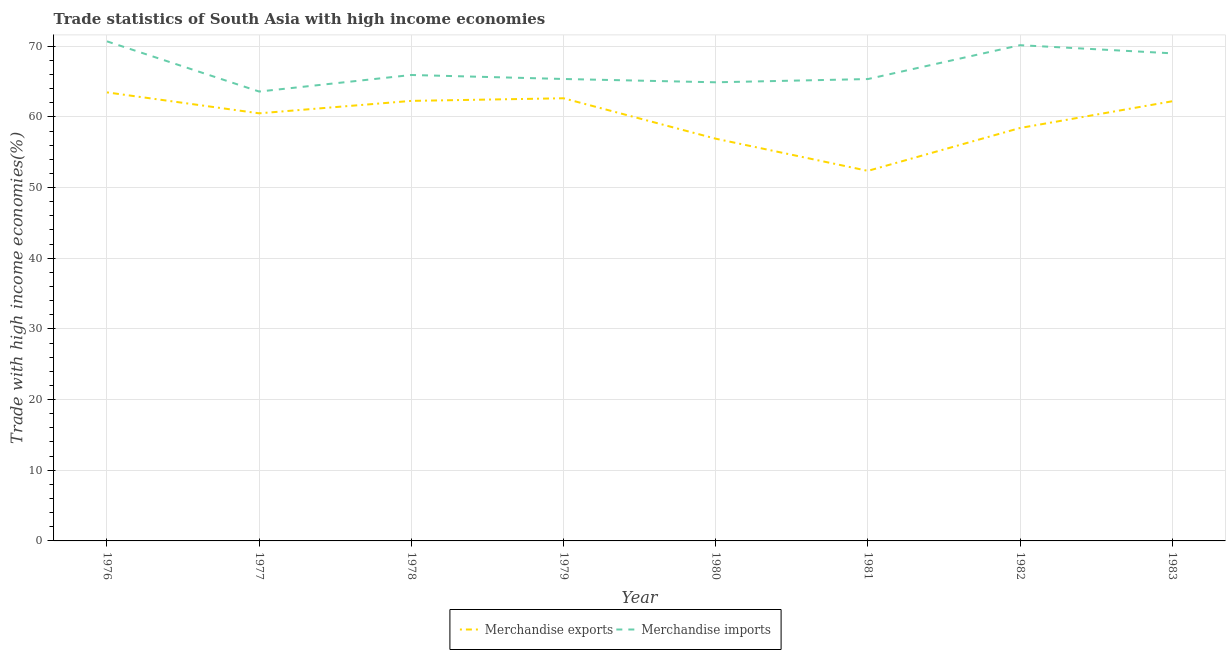How many different coloured lines are there?
Your answer should be compact. 2. Does the line corresponding to merchandise exports intersect with the line corresponding to merchandise imports?
Your answer should be compact. No. Is the number of lines equal to the number of legend labels?
Offer a very short reply. Yes. What is the merchandise imports in 1977?
Your answer should be very brief. 63.58. Across all years, what is the maximum merchandise imports?
Keep it short and to the point. 70.69. Across all years, what is the minimum merchandise exports?
Offer a very short reply. 52.36. In which year was the merchandise exports maximum?
Provide a succinct answer. 1976. What is the total merchandise exports in the graph?
Your response must be concise. 478.78. What is the difference between the merchandise imports in 1979 and that in 1980?
Give a very brief answer. 0.47. What is the difference between the merchandise imports in 1983 and the merchandise exports in 1981?
Your answer should be compact. 16.63. What is the average merchandise exports per year?
Your answer should be compact. 59.85. In the year 1977, what is the difference between the merchandise exports and merchandise imports?
Your response must be concise. -3.08. In how many years, is the merchandise exports greater than 32 %?
Offer a very short reply. 8. What is the ratio of the merchandise imports in 1976 to that in 1980?
Your answer should be very brief. 1.09. Is the merchandise imports in 1981 less than that in 1983?
Keep it short and to the point. Yes. Is the difference between the merchandise exports in 1978 and 1980 greater than the difference between the merchandise imports in 1978 and 1980?
Your response must be concise. Yes. What is the difference between the highest and the second highest merchandise imports?
Your answer should be very brief. 0.54. What is the difference between the highest and the lowest merchandise exports?
Your answer should be compact. 11.1. Is the sum of the merchandise imports in 1976 and 1979 greater than the maximum merchandise exports across all years?
Make the answer very short. Yes. Does the merchandise exports monotonically increase over the years?
Your answer should be very brief. No. Is the merchandise imports strictly greater than the merchandise exports over the years?
Make the answer very short. Yes. Is the merchandise imports strictly less than the merchandise exports over the years?
Your answer should be compact. No. How many lines are there?
Provide a succinct answer. 2. Does the graph contain grids?
Offer a very short reply. Yes. What is the title of the graph?
Make the answer very short. Trade statistics of South Asia with high income economies. What is the label or title of the Y-axis?
Ensure brevity in your answer.  Trade with high income economies(%). What is the Trade with high income economies(%) of Merchandise exports in 1976?
Offer a terse response. 63.47. What is the Trade with high income economies(%) in Merchandise imports in 1976?
Provide a succinct answer. 70.69. What is the Trade with high income economies(%) in Merchandise exports in 1977?
Keep it short and to the point. 60.5. What is the Trade with high income economies(%) of Merchandise imports in 1977?
Your answer should be very brief. 63.58. What is the Trade with high income economies(%) in Merchandise exports in 1978?
Keep it short and to the point. 62.26. What is the Trade with high income economies(%) of Merchandise imports in 1978?
Your response must be concise. 65.93. What is the Trade with high income economies(%) of Merchandise exports in 1979?
Keep it short and to the point. 62.63. What is the Trade with high income economies(%) of Merchandise imports in 1979?
Offer a terse response. 65.36. What is the Trade with high income economies(%) in Merchandise exports in 1980?
Ensure brevity in your answer.  56.91. What is the Trade with high income economies(%) of Merchandise imports in 1980?
Ensure brevity in your answer.  64.89. What is the Trade with high income economies(%) of Merchandise exports in 1981?
Make the answer very short. 52.36. What is the Trade with high income economies(%) of Merchandise imports in 1981?
Your response must be concise. 65.35. What is the Trade with high income economies(%) of Merchandise exports in 1982?
Make the answer very short. 58.43. What is the Trade with high income economies(%) in Merchandise imports in 1982?
Make the answer very short. 70.14. What is the Trade with high income economies(%) of Merchandise exports in 1983?
Your answer should be compact. 62.21. What is the Trade with high income economies(%) in Merchandise imports in 1983?
Give a very brief answer. 68.99. Across all years, what is the maximum Trade with high income economies(%) in Merchandise exports?
Your answer should be compact. 63.47. Across all years, what is the maximum Trade with high income economies(%) of Merchandise imports?
Make the answer very short. 70.69. Across all years, what is the minimum Trade with high income economies(%) in Merchandise exports?
Offer a very short reply. 52.36. Across all years, what is the minimum Trade with high income economies(%) in Merchandise imports?
Give a very brief answer. 63.58. What is the total Trade with high income economies(%) in Merchandise exports in the graph?
Your response must be concise. 478.78. What is the total Trade with high income economies(%) of Merchandise imports in the graph?
Give a very brief answer. 534.94. What is the difference between the Trade with high income economies(%) in Merchandise exports in 1976 and that in 1977?
Your answer should be very brief. 2.96. What is the difference between the Trade with high income economies(%) in Merchandise imports in 1976 and that in 1977?
Your answer should be very brief. 7.1. What is the difference between the Trade with high income economies(%) in Merchandise exports in 1976 and that in 1978?
Provide a succinct answer. 1.2. What is the difference between the Trade with high income economies(%) of Merchandise imports in 1976 and that in 1978?
Your response must be concise. 4.76. What is the difference between the Trade with high income economies(%) of Merchandise exports in 1976 and that in 1979?
Give a very brief answer. 0.83. What is the difference between the Trade with high income economies(%) of Merchandise imports in 1976 and that in 1979?
Provide a succinct answer. 5.32. What is the difference between the Trade with high income economies(%) of Merchandise exports in 1976 and that in 1980?
Your answer should be very brief. 6.55. What is the difference between the Trade with high income economies(%) of Merchandise imports in 1976 and that in 1980?
Provide a short and direct response. 5.79. What is the difference between the Trade with high income economies(%) in Merchandise exports in 1976 and that in 1981?
Your answer should be compact. 11.1. What is the difference between the Trade with high income economies(%) of Merchandise imports in 1976 and that in 1981?
Your response must be concise. 5.33. What is the difference between the Trade with high income economies(%) in Merchandise exports in 1976 and that in 1982?
Keep it short and to the point. 5.04. What is the difference between the Trade with high income economies(%) of Merchandise imports in 1976 and that in 1982?
Provide a short and direct response. 0.54. What is the difference between the Trade with high income economies(%) in Merchandise exports in 1976 and that in 1983?
Your response must be concise. 1.26. What is the difference between the Trade with high income economies(%) of Merchandise imports in 1976 and that in 1983?
Your answer should be compact. 1.7. What is the difference between the Trade with high income economies(%) of Merchandise exports in 1977 and that in 1978?
Offer a terse response. -1.76. What is the difference between the Trade with high income economies(%) of Merchandise imports in 1977 and that in 1978?
Provide a succinct answer. -2.34. What is the difference between the Trade with high income economies(%) in Merchandise exports in 1977 and that in 1979?
Your answer should be compact. -2.13. What is the difference between the Trade with high income economies(%) in Merchandise imports in 1977 and that in 1979?
Your answer should be very brief. -1.78. What is the difference between the Trade with high income economies(%) in Merchandise exports in 1977 and that in 1980?
Provide a succinct answer. 3.59. What is the difference between the Trade with high income economies(%) in Merchandise imports in 1977 and that in 1980?
Ensure brevity in your answer.  -1.31. What is the difference between the Trade with high income economies(%) of Merchandise exports in 1977 and that in 1981?
Your response must be concise. 8.14. What is the difference between the Trade with high income economies(%) of Merchandise imports in 1977 and that in 1981?
Provide a short and direct response. -1.77. What is the difference between the Trade with high income economies(%) of Merchandise exports in 1977 and that in 1982?
Provide a succinct answer. 2.08. What is the difference between the Trade with high income economies(%) of Merchandise imports in 1977 and that in 1982?
Provide a succinct answer. -6.56. What is the difference between the Trade with high income economies(%) of Merchandise exports in 1977 and that in 1983?
Offer a very short reply. -1.71. What is the difference between the Trade with high income economies(%) in Merchandise imports in 1977 and that in 1983?
Ensure brevity in your answer.  -5.41. What is the difference between the Trade with high income economies(%) of Merchandise exports in 1978 and that in 1979?
Provide a succinct answer. -0.37. What is the difference between the Trade with high income economies(%) in Merchandise imports in 1978 and that in 1979?
Offer a terse response. 0.56. What is the difference between the Trade with high income economies(%) of Merchandise exports in 1978 and that in 1980?
Offer a terse response. 5.35. What is the difference between the Trade with high income economies(%) of Merchandise imports in 1978 and that in 1980?
Your answer should be very brief. 1.03. What is the difference between the Trade with high income economies(%) in Merchandise exports in 1978 and that in 1981?
Ensure brevity in your answer.  9.9. What is the difference between the Trade with high income economies(%) in Merchandise imports in 1978 and that in 1981?
Offer a very short reply. 0.57. What is the difference between the Trade with high income economies(%) of Merchandise exports in 1978 and that in 1982?
Make the answer very short. 3.84. What is the difference between the Trade with high income economies(%) in Merchandise imports in 1978 and that in 1982?
Provide a succinct answer. -4.22. What is the difference between the Trade with high income economies(%) of Merchandise exports in 1978 and that in 1983?
Offer a very short reply. 0.05. What is the difference between the Trade with high income economies(%) of Merchandise imports in 1978 and that in 1983?
Provide a succinct answer. -3.06. What is the difference between the Trade with high income economies(%) of Merchandise exports in 1979 and that in 1980?
Your response must be concise. 5.72. What is the difference between the Trade with high income economies(%) in Merchandise imports in 1979 and that in 1980?
Your answer should be very brief. 0.47. What is the difference between the Trade with high income economies(%) in Merchandise exports in 1979 and that in 1981?
Your response must be concise. 10.27. What is the difference between the Trade with high income economies(%) in Merchandise imports in 1979 and that in 1981?
Make the answer very short. 0.01. What is the difference between the Trade with high income economies(%) in Merchandise exports in 1979 and that in 1982?
Give a very brief answer. 4.21. What is the difference between the Trade with high income economies(%) of Merchandise imports in 1979 and that in 1982?
Keep it short and to the point. -4.78. What is the difference between the Trade with high income economies(%) of Merchandise exports in 1979 and that in 1983?
Make the answer very short. 0.42. What is the difference between the Trade with high income economies(%) in Merchandise imports in 1979 and that in 1983?
Provide a short and direct response. -3.63. What is the difference between the Trade with high income economies(%) of Merchandise exports in 1980 and that in 1981?
Ensure brevity in your answer.  4.55. What is the difference between the Trade with high income economies(%) of Merchandise imports in 1980 and that in 1981?
Ensure brevity in your answer.  -0.46. What is the difference between the Trade with high income economies(%) in Merchandise exports in 1980 and that in 1982?
Provide a succinct answer. -1.51. What is the difference between the Trade with high income economies(%) of Merchandise imports in 1980 and that in 1982?
Offer a terse response. -5.25. What is the difference between the Trade with high income economies(%) in Merchandise exports in 1980 and that in 1983?
Ensure brevity in your answer.  -5.29. What is the difference between the Trade with high income economies(%) of Merchandise imports in 1980 and that in 1983?
Provide a short and direct response. -4.1. What is the difference between the Trade with high income economies(%) of Merchandise exports in 1981 and that in 1982?
Keep it short and to the point. -6.07. What is the difference between the Trade with high income economies(%) in Merchandise imports in 1981 and that in 1982?
Your answer should be very brief. -4.79. What is the difference between the Trade with high income economies(%) of Merchandise exports in 1981 and that in 1983?
Provide a short and direct response. -9.85. What is the difference between the Trade with high income economies(%) of Merchandise imports in 1981 and that in 1983?
Provide a succinct answer. -3.64. What is the difference between the Trade with high income economies(%) in Merchandise exports in 1982 and that in 1983?
Provide a short and direct response. -3.78. What is the difference between the Trade with high income economies(%) of Merchandise imports in 1982 and that in 1983?
Provide a succinct answer. 1.15. What is the difference between the Trade with high income economies(%) of Merchandise exports in 1976 and the Trade with high income economies(%) of Merchandise imports in 1977?
Ensure brevity in your answer.  -0.12. What is the difference between the Trade with high income economies(%) in Merchandise exports in 1976 and the Trade with high income economies(%) in Merchandise imports in 1978?
Your response must be concise. -2.46. What is the difference between the Trade with high income economies(%) in Merchandise exports in 1976 and the Trade with high income economies(%) in Merchandise imports in 1979?
Ensure brevity in your answer.  -1.9. What is the difference between the Trade with high income economies(%) of Merchandise exports in 1976 and the Trade with high income economies(%) of Merchandise imports in 1980?
Give a very brief answer. -1.43. What is the difference between the Trade with high income economies(%) of Merchandise exports in 1976 and the Trade with high income economies(%) of Merchandise imports in 1981?
Provide a succinct answer. -1.89. What is the difference between the Trade with high income economies(%) of Merchandise exports in 1976 and the Trade with high income economies(%) of Merchandise imports in 1982?
Offer a terse response. -6.68. What is the difference between the Trade with high income economies(%) of Merchandise exports in 1976 and the Trade with high income economies(%) of Merchandise imports in 1983?
Your response must be concise. -5.52. What is the difference between the Trade with high income economies(%) of Merchandise exports in 1977 and the Trade with high income economies(%) of Merchandise imports in 1978?
Make the answer very short. -5.42. What is the difference between the Trade with high income economies(%) in Merchandise exports in 1977 and the Trade with high income economies(%) in Merchandise imports in 1979?
Ensure brevity in your answer.  -4.86. What is the difference between the Trade with high income economies(%) in Merchandise exports in 1977 and the Trade with high income economies(%) in Merchandise imports in 1980?
Provide a short and direct response. -4.39. What is the difference between the Trade with high income economies(%) of Merchandise exports in 1977 and the Trade with high income economies(%) of Merchandise imports in 1981?
Provide a succinct answer. -4.85. What is the difference between the Trade with high income economies(%) of Merchandise exports in 1977 and the Trade with high income economies(%) of Merchandise imports in 1982?
Offer a very short reply. -9.64. What is the difference between the Trade with high income economies(%) of Merchandise exports in 1977 and the Trade with high income economies(%) of Merchandise imports in 1983?
Provide a succinct answer. -8.49. What is the difference between the Trade with high income economies(%) of Merchandise exports in 1978 and the Trade with high income economies(%) of Merchandise imports in 1979?
Make the answer very short. -3.1. What is the difference between the Trade with high income economies(%) of Merchandise exports in 1978 and the Trade with high income economies(%) of Merchandise imports in 1980?
Ensure brevity in your answer.  -2.63. What is the difference between the Trade with high income economies(%) of Merchandise exports in 1978 and the Trade with high income economies(%) of Merchandise imports in 1981?
Keep it short and to the point. -3.09. What is the difference between the Trade with high income economies(%) in Merchandise exports in 1978 and the Trade with high income economies(%) in Merchandise imports in 1982?
Ensure brevity in your answer.  -7.88. What is the difference between the Trade with high income economies(%) in Merchandise exports in 1978 and the Trade with high income economies(%) in Merchandise imports in 1983?
Provide a short and direct response. -6.73. What is the difference between the Trade with high income economies(%) in Merchandise exports in 1979 and the Trade with high income economies(%) in Merchandise imports in 1980?
Ensure brevity in your answer.  -2.26. What is the difference between the Trade with high income economies(%) of Merchandise exports in 1979 and the Trade with high income economies(%) of Merchandise imports in 1981?
Your response must be concise. -2.72. What is the difference between the Trade with high income economies(%) in Merchandise exports in 1979 and the Trade with high income economies(%) in Merchandise imports in 1982?
Your response must be concise. -7.51. What is the difference between the Trade with high income economies(%) in Merchandise exports in 1979 and the Trade with high income economies(%) in Merchandise imports in 1983?
Your answer should be compact. -6.36. What is the difference between the Trade with high income economies(%) in Merchandise exports in 1980 and the Trade with high income economies(%) in Merchandise imports in 1981?
Make the answer very short. -8.44. What is the difference between the Trade with high income economies(%) of Merchandise exports in 1980 and the Trade with high income economies(%) of Merchandise imports in 1982?
Offer a terse response. -13.23. What is the difference between the Trade with high income economies(%) of Merchandise exports in 1980 and the Trade with high income economies(%) of Merchandise imports in 1983?
Your answer should be compact. -12.08. What is the difference between the Trade with high income economies(%) of Merchandise exports in 1981 and the Trade with high income economies(%) of Merchandise imports in 1982?
Make the answer very short. -17.78. What is the difference between the Trade with high income economies(%) in Merchandise exports in 1981 and the Trade with high income economies(%) in Merchandise imports in 1983?
Give a very brief answer. -16.63. What is the difference between the Trade with high income economies(%) of Merchandise exports in 1982 and the Trade with high income economies(%) of Merchandise imports in 1983?
Provide a succinct answer. -10.56. What is the average Trade with high income economies(%) in Merchandise exports per year?
Offer a terse response. 59.85. What is the average Trade with high income economies(%) in Merchandise imports per year?
Provide a short and direct response. 66.87. In the year 1976, what is the difference between the Trade with high income economies(%) in Merchandise exports and Trade with high income economies(%) in Merchandise imports?
Offer a very short reply. -7.22. In the year 1977, what is the difference between the Trade with high income economies(%) of Merchandise exports and Trade with high income economies(%) of Merchandise imports?
Provide a succinct answer. -3.08. In the year 1978, what is the difference between the Trade with high income economies(%) in Merchandise exports and Trade with high income economies(%) in Merchandise imports?
Provide a succinct answer. -3.66. In the year 1979, what is the difference between the Trade with high income economies(%) of Merchandise exports and Trade with high income economies(%) of Merchandise imports?
Offer a very short reply. -2.73. In the year 1980, what is the difference between the Trade with high income economies(%) in Merchandise exports and Trade with high income economies(%) in Merchandise imports?
Provide a short and direct response. -7.98. In the year 1981, what is the difference between the Trade with high income economies(%) of Merchandise exports and Trade with high income economies(%) of Merchandise imports?
Provide a short and direct response. -12.99. In the year 1982, what is the difference between the Trade with high income economies(%) in Merchandise exports and Trade with high income economies(%) in Merchandise imports?
Offer a very short reply. -11.72. In the year 1983, what is the difference between the Trade with high income economies(%) in Merchandise exports and Trade with high income economies(%) in Merchandise imports?
Provide a short and direct response. -6.78. What is the ratio of the Trade with high income economies(%) in Merchandise exports in 1976 to that in 1977?
Make the answer very short. 1.05. What is the ratio of the Trade with high income economies(%) of Merchandise imports in 1976 to that in 1977?
Keep it short and to the point. 1.11. What is the ratio of the Trade with high income economies(%) of Merchandise exports in 1976 to that in 1978?
Keep it short and to the point. 1.02. What is the ratio of the Trade with high income economies(%) of Merchandise imports in 1976 to that in 1978?
Your answer should be very brief. 1.07. What is the ratio of the Trade with high income economies(%) in Merchandise exports in 1976 to that in 1979?
Your answer should be very brief. 1.01. What is the ratio of the Trade with high income economies(%) of Merchandise imports in 1976 to that in 1979?
Keep it short and to the point. 1.08. What is the ratio of the Trade with high income economies(%) in Merchandise exports in 1976 to that in 1980?
Provide a succinct answer. 1.12. What is the ratio of the Trade with high income economies(%) of Merchandise imports in 1976 to that in 1980?
Your answer should be very brief. 1.09. What is the ratio of the Trade with high income economies(%) of Merchandise exports in 1976 to that in 1981?
Your answer should be very brief. 1.21. What is the ratio of the Trade with high income economies(%) in Merchandise imports in 1976 to that in 1981?
Provide a short and direct response. 1.08. What is the ratio of the Trade with high income economies(%) in Merchandise exports in 1976 to that in 1982?
Offer a very short reply. 1.09. What is the ratio of the Trade with high income economies(%) of Merchandise imports in 1976 to that in 1982?
Provide a succinct answer. 1.01. What is the ratio of the Trade with high income economies(%) of Merchandise exports in 1976 to that in 1983?
Ensure brevity in your answer.  1.02. What is the ratio of the Trade with high income economies(%) of Merchandise imports in 1976 to that in 1983?
Give a very brief answer. 1.02. What is the ratio of the Trade with high income economies(%) of Merchandise exports in 1977 to that in 1978?
Keep it short and to the point. 0.97. What is the ratio of the Trade with high income economies(%) of Merchandise imports in 1977 to that in 1978?
Your response must be concise. 0.96. What is the ratio of the Trade with high income economies(%) in Merchandise imports in 1977 to that in 1979?
Your response must be concise. 0.97. What is the ratio of the Trade with high income economies(%) in Merchandise exports in 1977 to that in 1980?
Offer a very short reply. 1.06. What is the ratio of the Trade with high income economies(%) in Merchandise imports in 1977 to that in 1980?
Keep it short and to the point. 0.98. What is the ratio of the Trade with high income economies(%) in Merchandise exports in 1977 to that in 1981?
Provide a short and direct response. 1.16. What is the ratio of the Trade with high income economies(%) in Merchandise exports in 1977 to that in 1982?
Offer a terse response. 1.04. What is the ratio of the Trade with high income economies(%) of Merchandise imports in 1977 to that in 1982?
Keep it short and to the point. 0.91. What is the ratio of the Trade with high income economies(%) in Merchandise exports in 1977 to that in 1983?
Ensure brevity in your answer.  0.97. What is the ratio of the Trade with high income economies(%) in Merchandise imports in 1977 to that in 1983?
Make the answer very short. 0.92. What is the ratio of the Trade with high income economies(%) of Merchandise exports in 1978 to that in 1979?
Your answer should be very brief. 0.99. What is the ratio of the Trade with high income economies(%) of Merchandise imports in 1978 to that in 1979?
Keep it short and to the point. 1.01. What is the ratio of the Trade with high income economies(%) of Merchandise exports in 1978 to that in 1980?
Your response must be concise. 1.09. What is the ratio of the Trade with high income economies(%) in Merchandise imports in 1978 to that in 1980?
Your answer should be very brief. 1.02. What is the ratio of the Trade with high income economies(%) in Merchandise exports in 1978 to that in 1981?
Offer a very short reply. 1.19. What is the ratio of the Trade with high income economies(%) in Merchandise imports in 1978 to that in 1981?
Your answer should be very brief. 1.01. What is the ratio of the Trade with high income economies(%) in Merchandise exports in 1978 to that in 1982?
Give a very brief answer. 1.07. What is the ratio of the Trade with high income economies(%) in Merchandise imports in 1978 to that in 1982?
Provide a short and direct response. 0.94. What is the ratio of the Trade with high income economies(%) in Merchandise imports in 1978 to that in 1983?
Offer a terse response. 0.96. What is the ratio of the Trade with high income economies(%) of Merchandise exports in 1979 to that in 1980?
Your response must be concise. 1.1. What is the ratio of the Trade with high income economies(%) of Merchandise exports in 1979 to that in 1981?
Give a very brief answer. 1.2. What is the ratio of the Trade with high income economies(%) of Merchandise imports in 1979 to that in 1981?
Offer a terse response. 1. What is the ratio of the Trade with high income economies(%) of Merchandise exports in 1979 to that in 1982?
Keep it short and to the point. 1.07. What is the ratio of the Trade with high income economies(%) in Merchandise imports in 1979 to that in 1982?
Provide a short and direct response. 0.93. What is the ratio of the Trade with high income economies(%) in Merchandise exports in 1979 to that in 1983?
Keep it short and to the point. 1.01. What is the ratio of the Trade with high income economies(%) of Merchandise exports in 1980 to that in 1981?
Your answer should be compact. 1.09. What is the ratio of the Trade with high income economies(%) in Merchandise exports in 1980 to that in 1982?
Provide a short and direct response. 0.97. What is the ratio of the Trade with high income economies(%) of Merchandise imports in 1980 to that in 1982?
Provide a short and direct response. 0.93. What is the ratio of the Trade with high income economies(%) of Merchandise exports in 1980 to that in 1983?
Provide a succinct answer. 0.91. What is the ratio of the Trade with high income economies(%) in Merchandise imports in 1980 to that in 1983?
Your answer should be very brief. 0.94. What is the ratio of the Trade with high income economies(%) in Merchandise exports in 1981 to that in 1982?
Give a very brief answer. 0.9. What is the ratio of the Trade with high income economies(%) of Merchandise imports in 1981 to that in 1982?
Your answer should be compact. 0.93. What is the ratio of the Trade with high income economies(%) in Merchandise exports in 1981 to that in 1983?
Offer a very short reply. 0.84. What is the ratio of the Trade with high income economies(%) of Merchandise imports in 1981 to that in 1983?
Your response must be concise. 0.95. What is the ratio of the Trade with high income economies(%) in Merchandise exports in 1982 to that in 1983?
Offer a terse response. 0.94. What is the ratio of the Trade with high income economies(%) in Merchandise imports in 1982 to that in 1983?
Offer a terse response. 1.02. What is the difference between the highest and the second highest Trade with high income economies(%) in Merchandise exports?
Keep it short and to the point. 0.83. What is the difference between the highest and the second highest Trade with high income economies(%) in Merchandise imports?
Your response must be concise. 0.54. What is the difference between the highest and the lowest Trade with high income economies(%) in Merchandise exports?
Provide a short and direct response. 11.1. What is the difference between the highest and the lowest Trade with high income economies(%) of Merchandise imports?
Give a very brief answer. 7.1. 